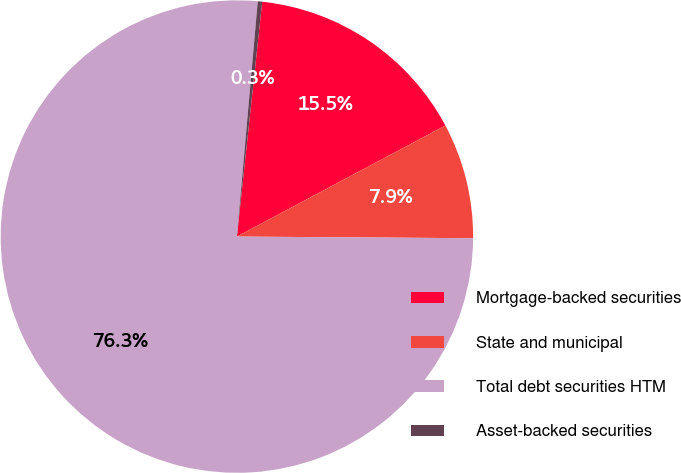Convert chart. <chart><loc_0><loc_0><loc_500><loc_500><pie_chart><fcel>Mortgage-backed securities<fcel>State and municipal<fcel>Total debt securities HTM<fcel>Asset-backed securities<nl><fcel>15.5%<fcel>7.9%<fcel>76.29%<fcel>0.3%<nl></chart> 